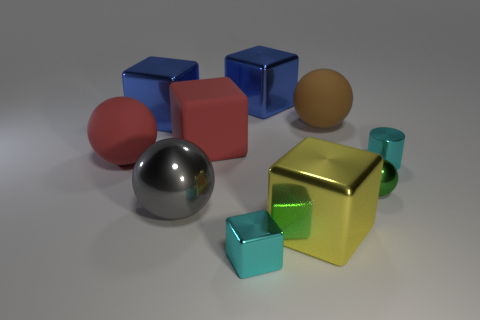Is the small metal cylinder the same color as the tiny metallic block?
Your answer should be very brief. Yes. There is a cyan metallic object right of the tiny block; what is its size?
Your response must be concise. Small. What is the material of the tiny cyan object on the left side of the big cube that is in front of the large sphere that is to the left of the gray metal ball?
Keep it short and to the point. Metal. Do the brown thing and the yellow shiny object have the same shape?
Your response must be concise. No. What number of matte objects are large red objects or big yellow objects?
Your response must be concise. 2. What number of small metal spheres are there?
Your response must be concise. 1. The other rubber ball that is the same size as the brown ball is what color?
Offer a terse response. Red. Do the yellow metallic thing and the red matte block have the same size?
Ensure brevity in your answer.  Yes. The object that is the same color as the large rubber cube is what shape?
Provide a short and direct response. Sphere. There is a gray shiny sphere; does it have the same size as the rubber ball right of the red ball?
Give a very brief answer. Yes. 